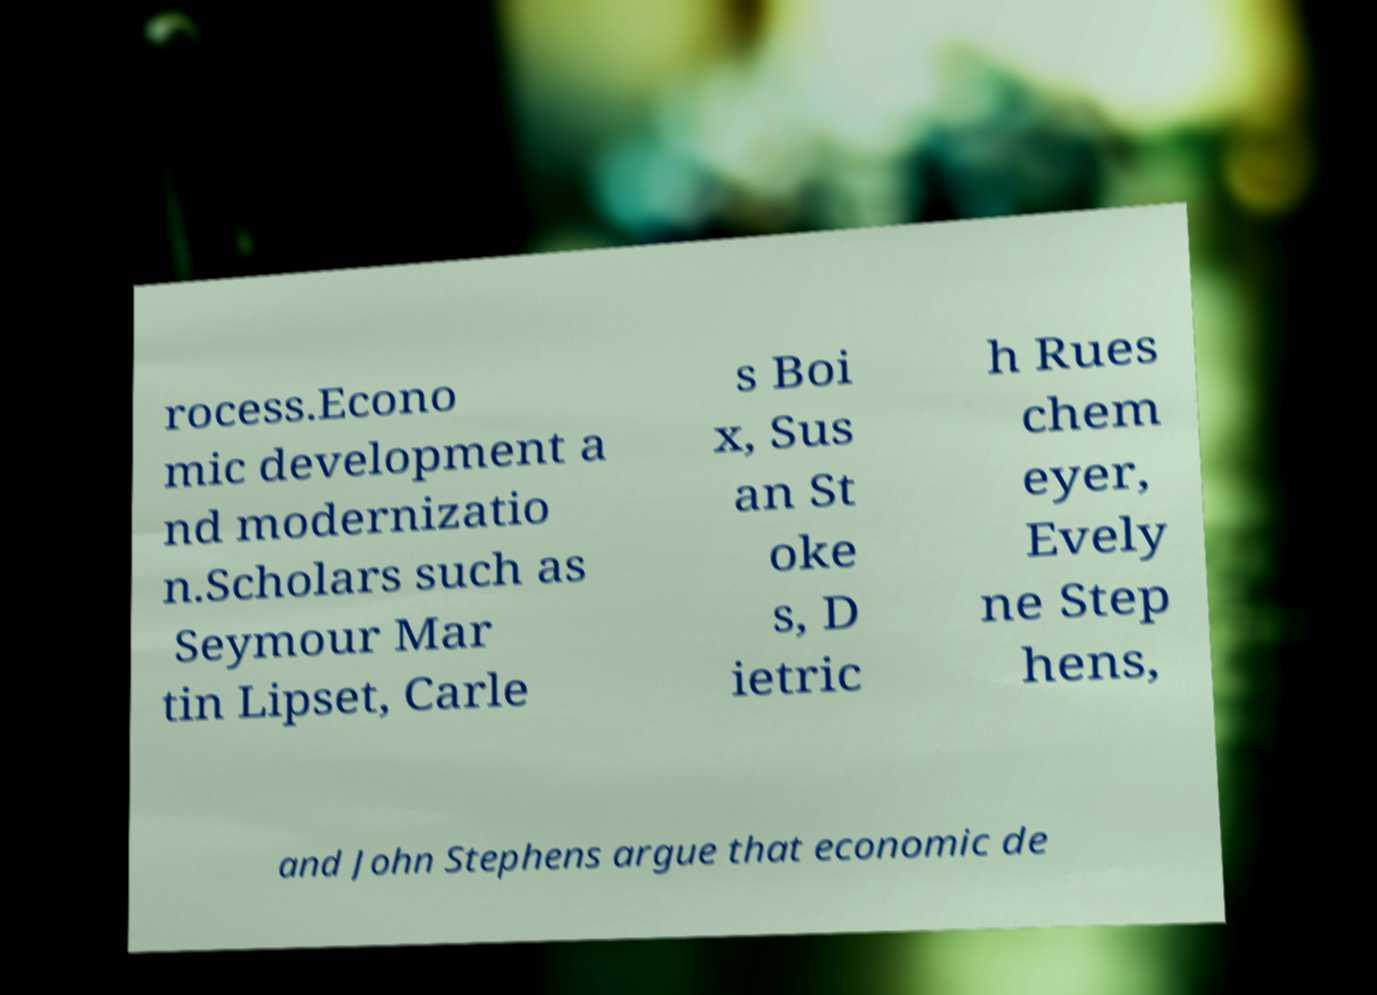For documentation purposes, I need the text within this image transcribed. Could you provide that? rocess.Econo mic development a nd modernizatio n.Scholars such as Seymour Mar tin Lipset, Carle s Boi x, Sus an St oke s, D ietric h Rues chem eyer, Evely ne Step hens, and John Stephens argue that economic de 